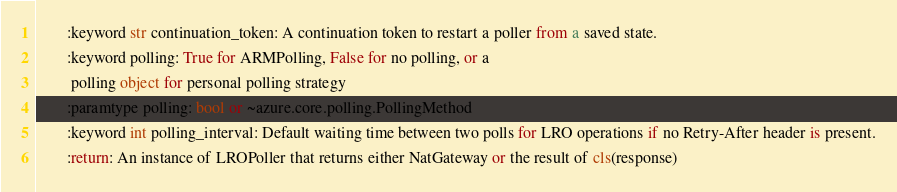Convert code to text. <code><loc_0><loc_0><loc_500><loc_500><_Python_>        :keyword str continuation_token: A continuation token to restart a poller from a saved state.
        :keyword polling: True for ARMPolling, False for no polling, or a
         polling object for personal polling strategy
        :paramtype polling: bool or ~azure.core.polling.PollingMethod
        :keyword int polling_interval: Default waiting time between two polls for LRO operations if no Retry-After header is present.
        :return: An instance of LROPoller that returns either NatGateway or the result of cls(response)</code> 